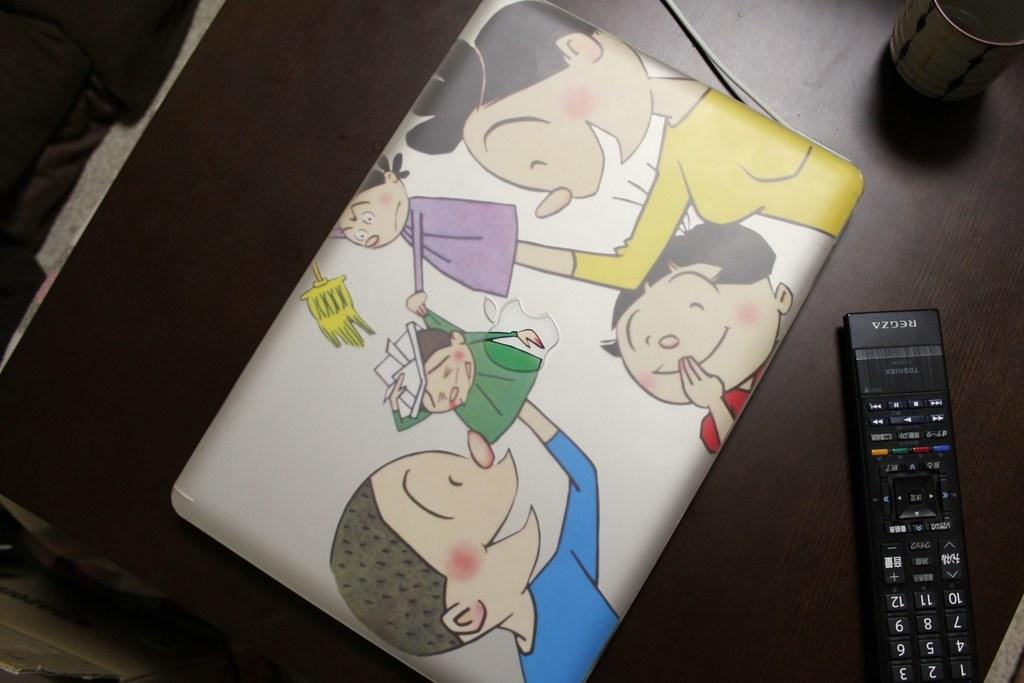<image>
Present a compact description of the photo's key features. A Regza remote control lays next to a laptop with a cartoon sleeve. 